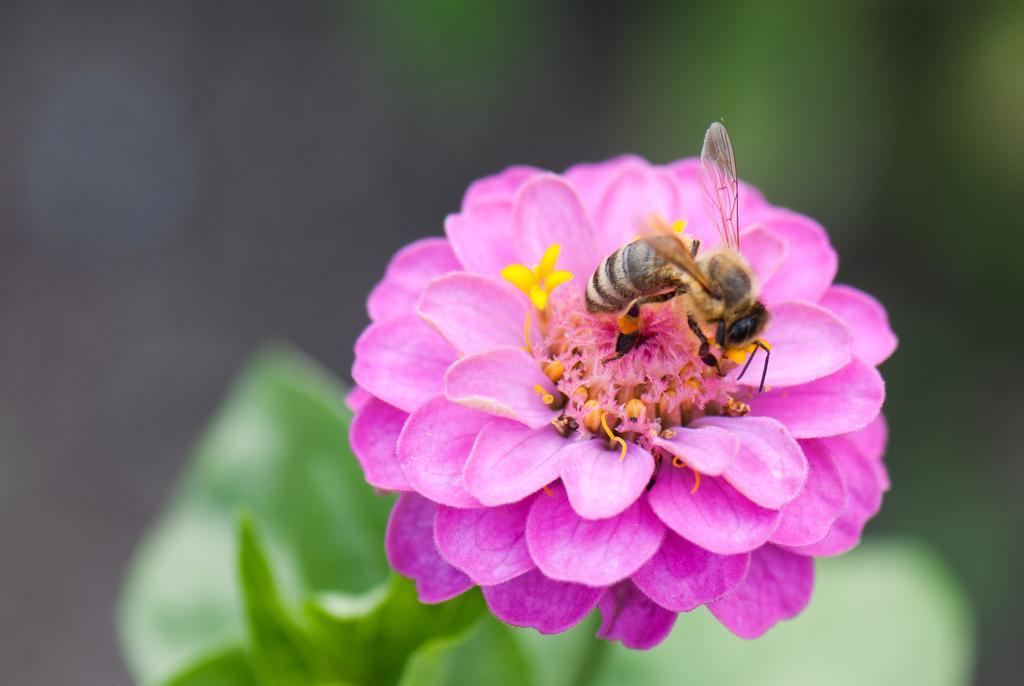How would you summarize this image in a sentence or two? There is a bee on a pink color flower of a plant which is having green color leaves. And the background is blurred. 